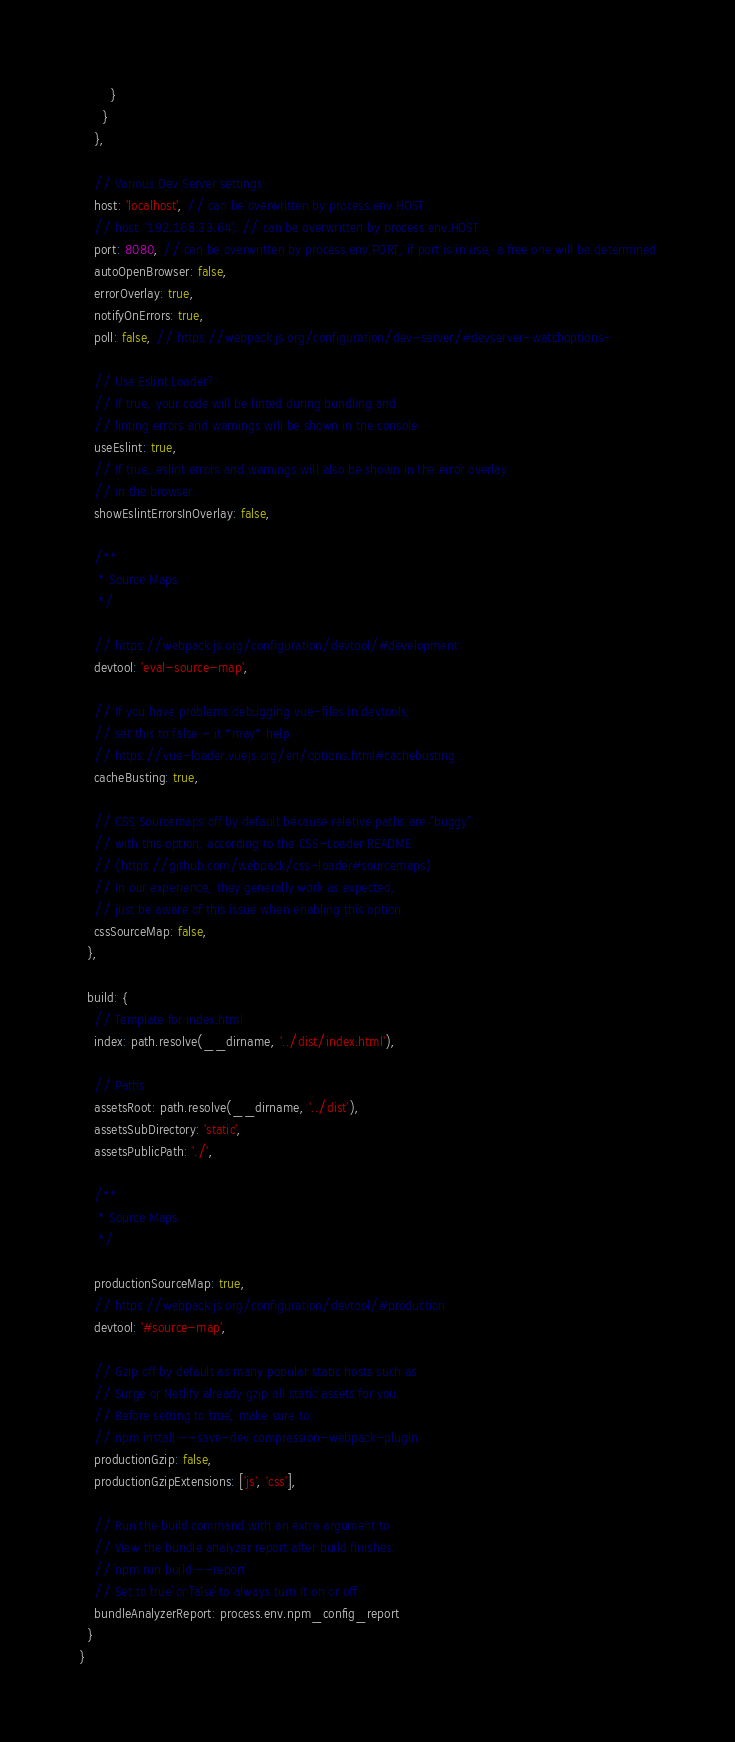<code> <loc_0><loc_0><loc_500><loc_500><_JavaScript_>        }
      }
    },

    // Various Dev Server settings
    host: 'localhost', // can be overwritten by process.env.HOST
    // host: '192.168.33.64', // can be overwritten by process.env.HOST
    port: 8080, // can be overwritten by process.env.PORT, if port is in use, a free one will be determined
    autoOpenBrowser: false,
    errorOverlay: true,
    notifyOnErrors: true,
    poll: false, // https://webpack.js.org/configuration/dev-server/#devserver-watchoptions-

    // Use Eslint Loader?
    // If true, your code will be linted during bundling and
    // linting errors and warnings will be shown in the console.
    useEslint: true,
    // If true, eslint errors and warnings will also be shown in the error overlay
    // in the browser.
    showEslintErrorsInOverlay: false,

    /**
     * Source Maps
     */

    // https://webpack.js.org/configuration/devtool/#development
    devtool: 'eval-source-map',

    // If you have problems debugging vue-files in devtools,
    // set this to false - it *may* help
    // https://vue-loader.vuejs.org/en/options.html#cachebusting
    cacheBusting: true,

    // CSS Sourcemaps off by default because relative paths are "buggy"
    // with this option, according to the CSS-Loader README
    // (https://github.com/webpack/css-loader#sourcemaps)
    // In our experience, they generally work as expected,
    // just be aware of this issue when enabling this option.
    cssSourceMap: false,
  },

  build: {
    // Template for index.html
    index: path.resolve(__dirname, '../dist/index.html'),

    // Paths
    assetsRoot: path.resolve(__dirname, '../dist'),
    assetsSubDirectory: 'static',
    assetsPublicPath: './',

    /**
     * Source Maps
     */

    productionSourceMap: true,
    // https://webpack.js.org/configuration/devtool/#production
    devtool: '#source-map',

    // Gzip off by default as many popular static hosts such as
    // Surge or Netlify already gzip all static assets for you.
    // Before setting to `true`, make sure to:
    // npm install --save-dev compression-webpack-plugin
    productionGzip: false,
    productionGzipExtensions: ['js', 'css'],

    // Run the build command with an extra argument to
    // View the bundle analyzer report after build finishes:
    // `npm run build --report`
    // Set to `true` or `false` to always turn it on or off
    bundleAnalyzerReport: process.env.npm_config_report
  }
}
</code> 